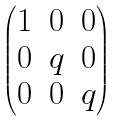<formula> <loc_0><loc_0><loc_500><loc_500>\begin{pmatrix} 1 & 0 & 0 \\ 0 & q & 0 \\ 0 & 0 & q \\ \end{pmatrix}</formula> 